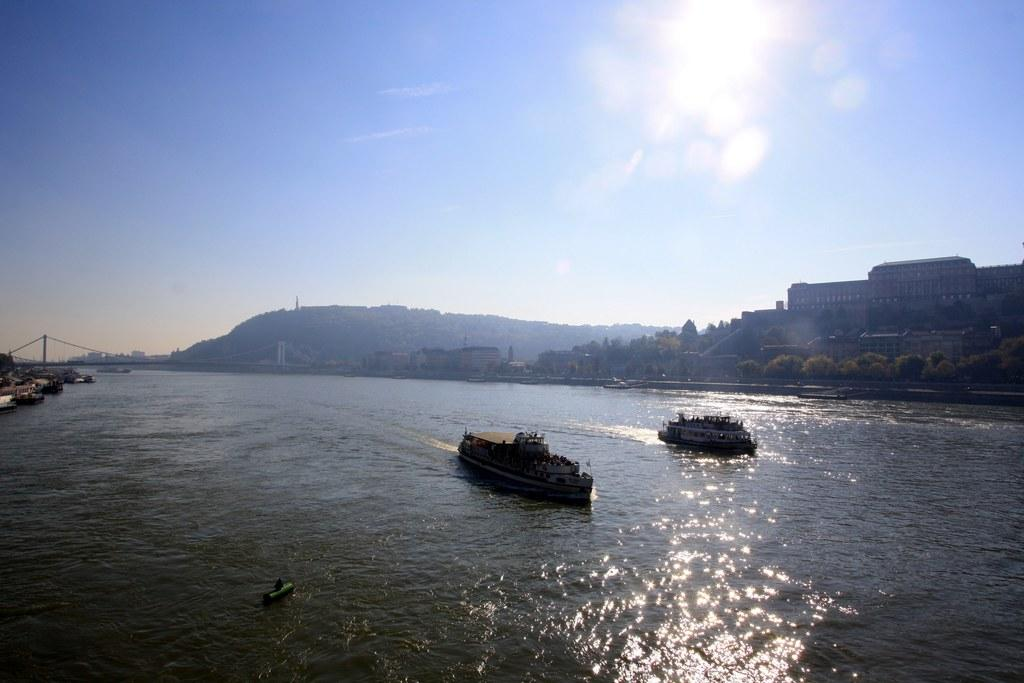What is on the water in the image? There are ships on the water in the image. What type of vegetation can be seen in the image? There are trees visible in the image. What type of structures can be seen in the image? There are buildings visible in the image. What geographical feature is visible in the image? There is a hill visible in the image. What is visible above the land and water in the image? The sky is visible in the image. Where is the bridge located in the image? The bridge is on the left side of the image. What type of mint can be seen growing on the bridge in the image? There is no mint visible in the image, and the bridge does not have any plants growing on it. What type of button can be seen on the ships in the image? There are no buttons visible on the ships in the image; they are not mentioned in the provided facts. 